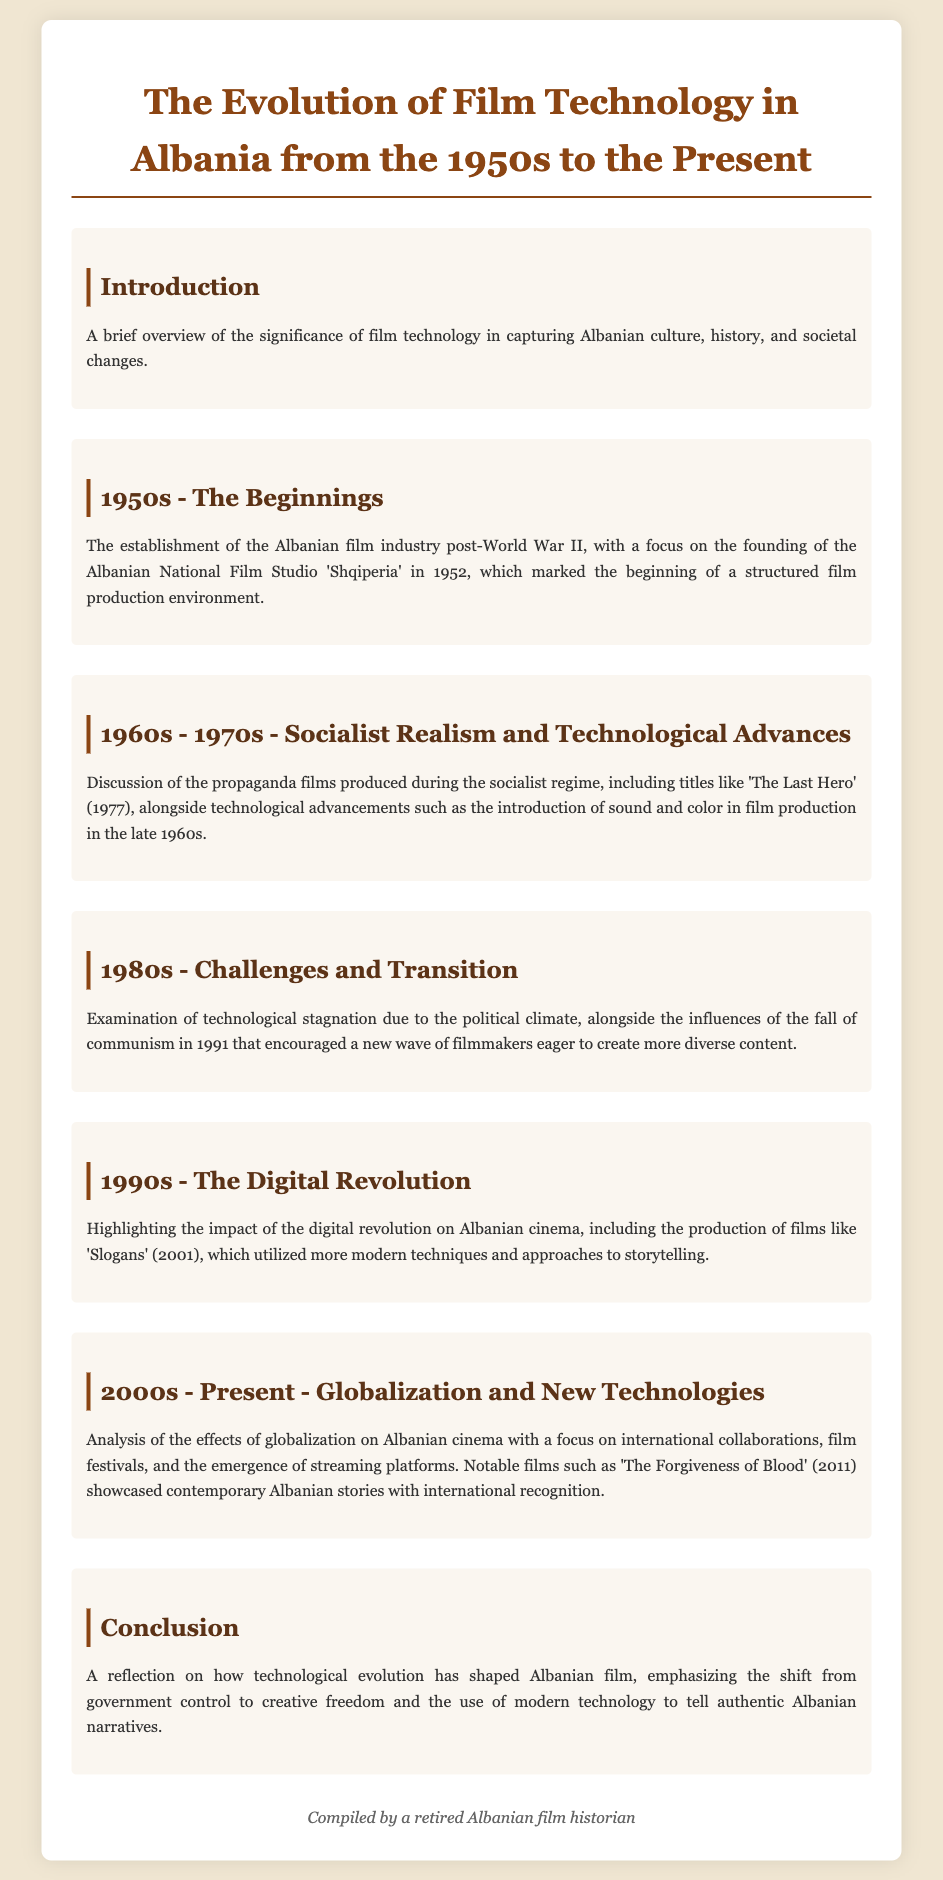What was the founding year of the Albanian National Film Studio? The document states that the Albanian National Film Studio 'Shqiperia' was founded in 1952.
Answer: 1952 Which propaganda film was released in 1977? The document mentions 'The Last Hero' as a propaganda film produced during the socialist regime in 1977.
Answer: The Last Hero What major political event in Albania occurred in 1991? The fall of communism in 1991 is highlighted as a significant event that influenced new filmmakers in Albania.
Answer: Fall of communism What film marked the impact of the digital revolution on Albanian cinema? The document indicates that 'Slogans' (2001) is a notable film that utilized modern techniques during the digital revolution.
Answer: Slogans Which film, released in 2011, showcased contemporary Albanian stories? The document states that 'The Forgiveness of Blood' (2011) was significant in showcasing contemporary Albanian narratives.
Answer: The Forgiveness of Blood How did the 1980s affect technological advancements in Albanian film? The document describes a technological stagnation due to the political climate in the 1980s.
Answer: Stagnation What was a key focus of the 2000s in Albanian cinema? The document discusses globalization, international collaborations, and the emergence of streaming platforms as key focuses.
Answer: Globalization What is the general theme of the document's conclusion? The conclusion reflects on the shift from government control to creative freedom in Albanian film technology.
Answer: Creative freedom 